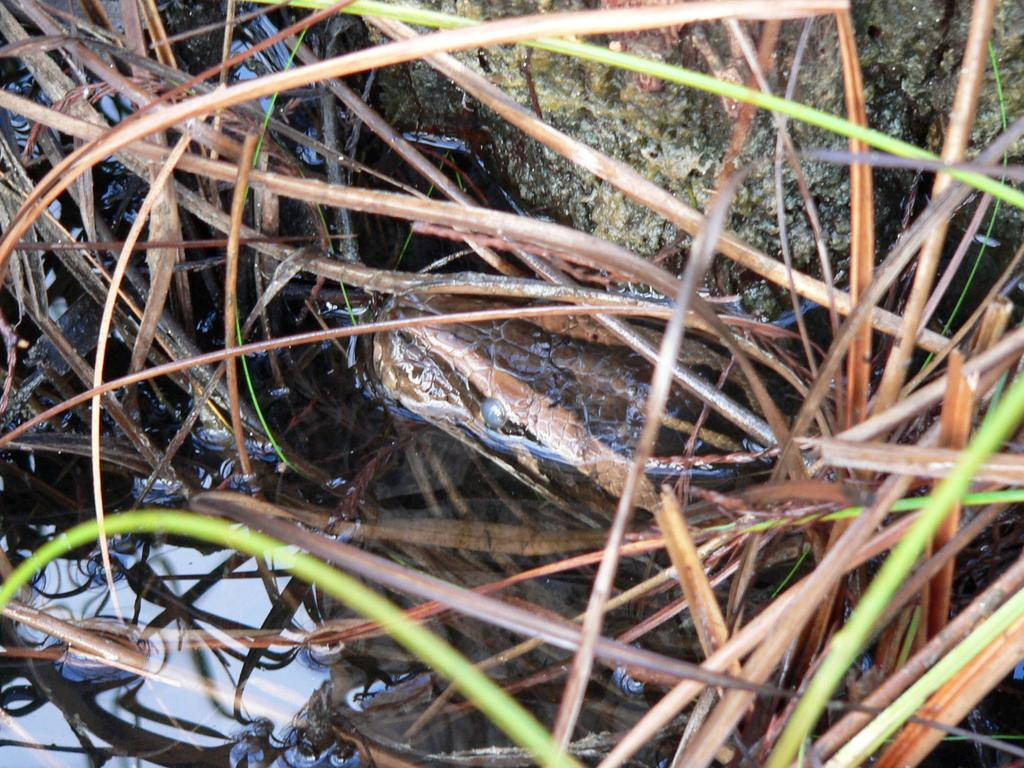What type of animal is in the image? There is a snake in the image. What natural element is present in the image? There is water visible in the image. What type of vegetation can be seen in the image? There is grass in the image. What geological feature is present in the image? There is a rock in the image. What type of soda is being served in the image? There is no soda present in the image; it features a snake, water, grass, and a rock. What decisions are being made by the committee in the image? There is no committee present in the image; it features a snake, water, grass, and a rock. 